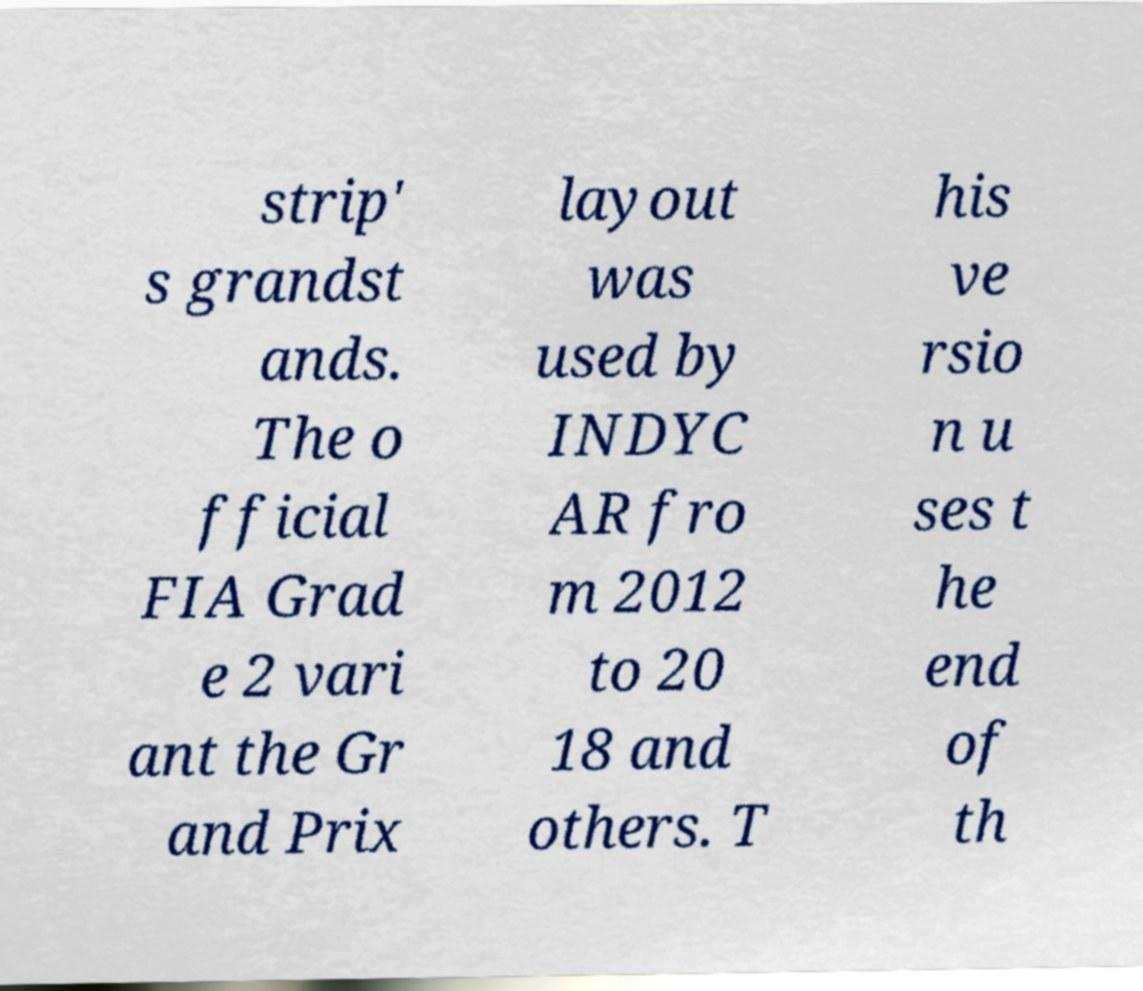What messages or text are displayed in this image? I need them in a readable, typed format. strip' s grandst ands. The o fficial FIA Grad e 2 vari ant the Gr and Prix layout was used by INDYC AR fro m 2012 to 20 18 and others. T his ve rsio n u ses t he end of th 